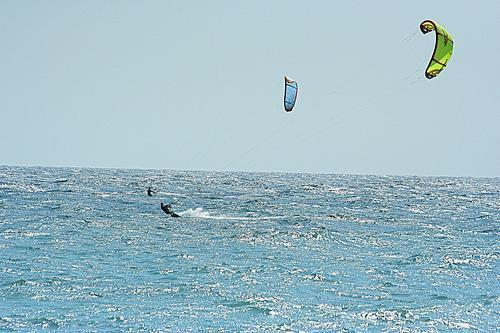How many people are in the photo?
Give a very brief answer. 2. 